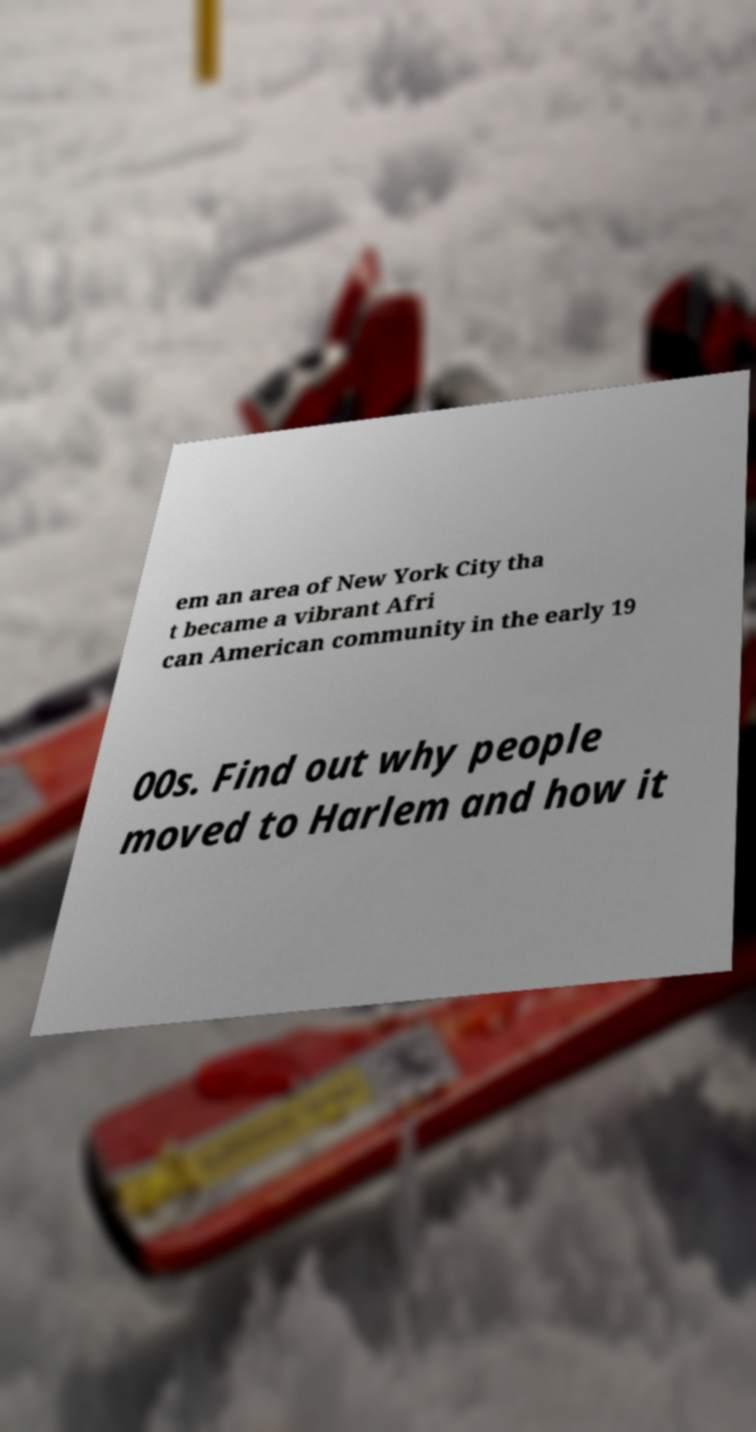Can you read and provide the text displayed in the image?This photo seems to have some interesting text. Can you extract and type it out for me? em an area of New York City tha t became a vibrant Afri can American community in the early 19 00s. Find out why people moved to Harlem and how it 